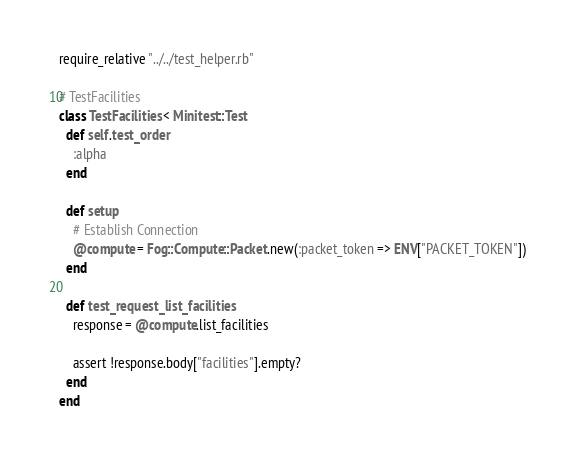Convert code to text. <code><loc_0><loc_0><loc_500><loc_500><_Ruby_>require_relative "../../test_helper.rb"

# TestFacilities
class TestFacilities < Minitest::Test
  def self.test_order
    :alpha
  end

  def setup
    # Establish Connection
    @compute = Fog::Compute::Packet.new(:packet_token => ENV["PACKET_TOKEN"])
  end

  def test_request_list_facilities
    response = @compute.list_facilities

    assert !response.body["facilities"].empty?
  end
end
</code> 